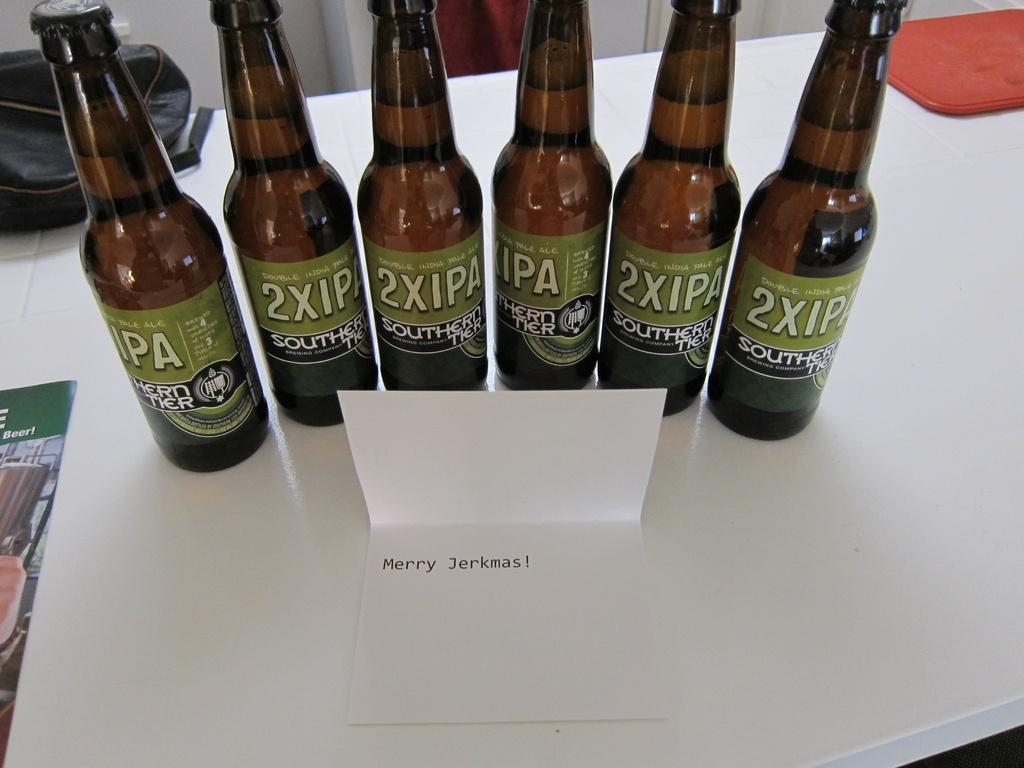<image>
Offer a succinct explanation of the picture presented. Several bottles of 2XIPA southern tea are lined up on a white counter. 